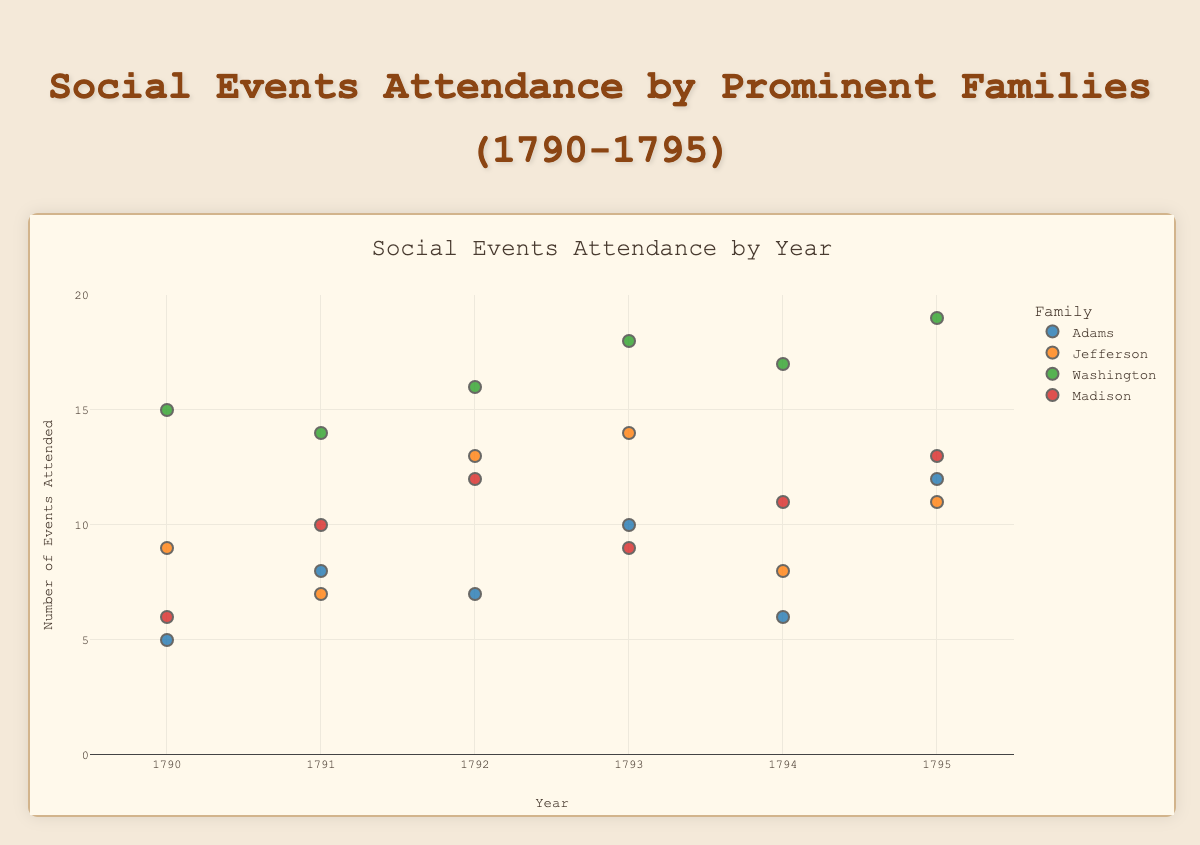What is the time period covered in the figure? The x-axis indicates the years, ranging from 1790 to 1795.
Answer: 1790-1795 Which family attended the highest number of events in any single year? Look for the largest y-value. Washington family attended 19 events in 1795.
Answer: Washington How many events did the Adams family attend in 1793? Locate the data point for the Adams family in 1793, which shows 10 events.
Answer: 10 Which family attended more events on average, the Adams family or the Jefferson family? Sum the number of events for each family, then calculate the average over the six years. Adams: (5+8+7+10+6+12)/6 = 48/6 = 8, Jefferson: (9+7+13+14+8+11)/6 = 62/6 ≈ 10.33
Answer: Jefferson Did the Madison family show an increasing trend in event attendance over the years? Observe the scatter plot points for the Madison family. 1790 (6), 1791 (10), 1792 (12), 1793 (9), 1794 (11), 1795 (13); the line generally increases.
Answer: Yes Compare the number of events attended by the Adams and Madison families in 1794. Adams attended 6 events, Madison attended 11 events in 1794. Madison attended more.
Answer: Madison What is the range of events attended by the Washington family? Identify the smallest and largest y-values for Washington. The range is 15 to 19 events.
Answer: 15-19 What is the overall trend in event attendance for the Jefferson family? Track Jefferson's points from 1790 to 1795; 9, 7, 13, 14, 8, and 11. The trend does not consistently increase or decrease.
Answer: No clear trend Which family had the least variation in the number of events attended? Compare variations (spread) in y-values for each family. Adams shows values from 5 to 12; Jefferson from 7 to 14; Madison from 6 to 13; Washington from 15 to 19. Adams has the least variation.
Answer: Adams Between 1790 and 1795, which family showed the largest single-year jump in event attendance? Check the biggest difference between consecutive years for each family. Jefferson from 7 (1791) to 13 (1792) shows an increase of 6 events.
Answer: Jefferson 